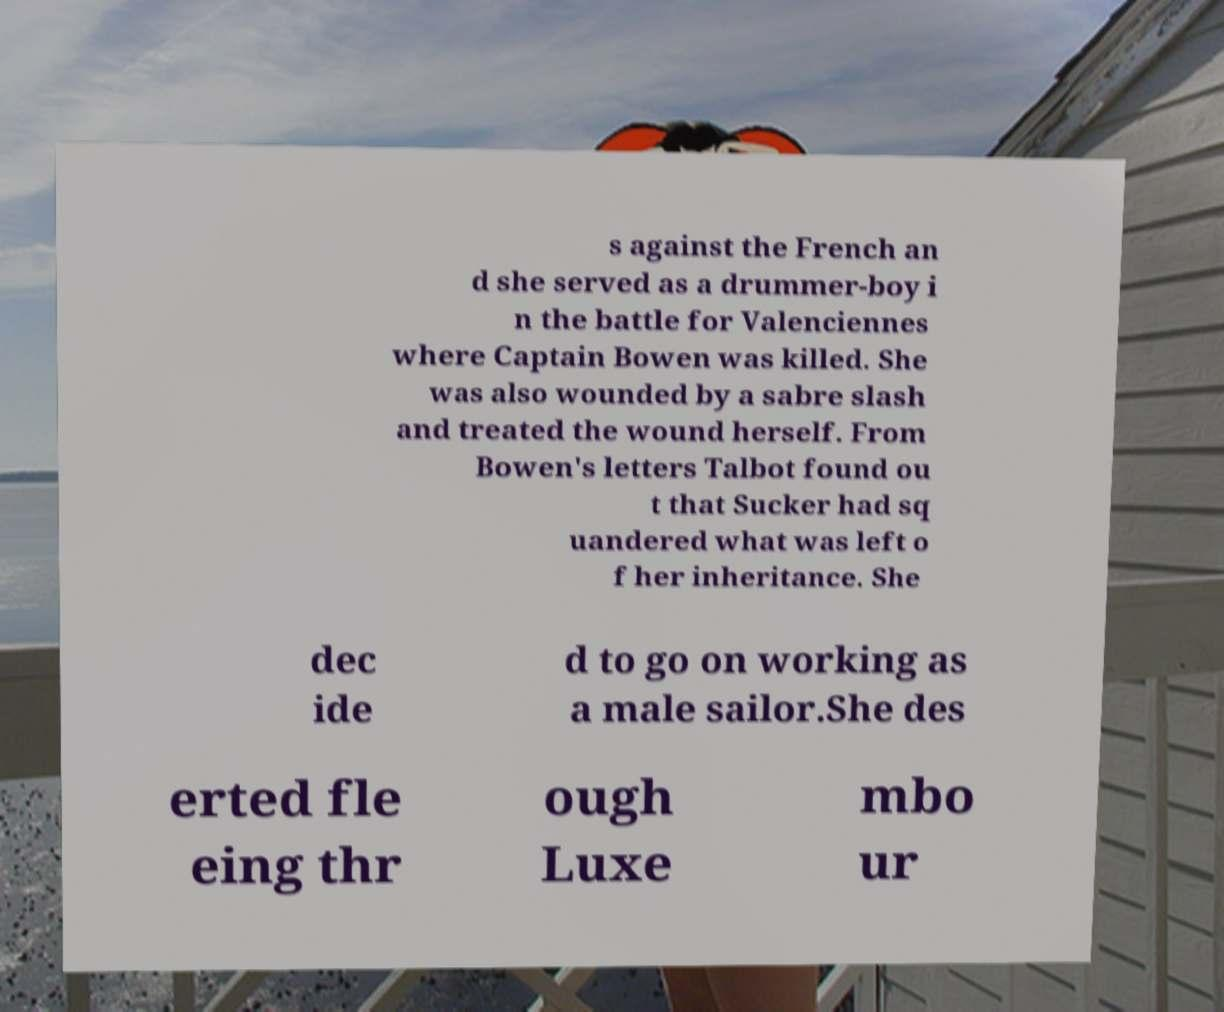Could you assist in decoding the text presented in this image and type it out clearly? s against the French an d she served as a drummer-boy i n the battle for Valenciennes where Captain Bowen was killed. She was also wounded by a sabre slash and treated the wound herself. From Bowen's letters Talbot found ou t that Sucker had sq uandered what was left o f her inheritance. She dec ide d to go on working as a male sailor.She des erted fle eing thr ough Luxe mbo ur 